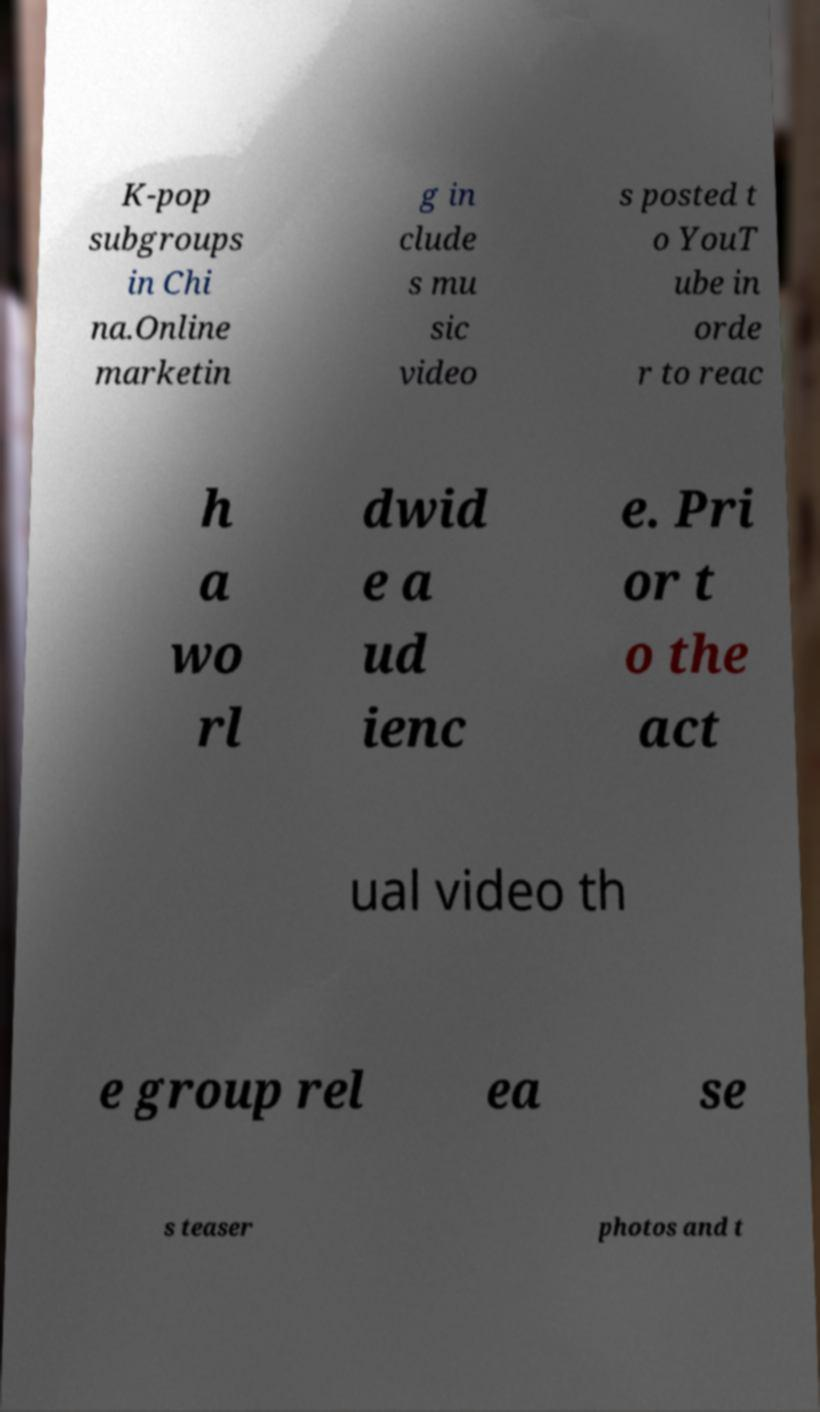What messages or text are displayed in this image? I need them in a readable, typed format. K-pop subgroups in Chi na.Online marketin g in clude s mu sic video s posted t o YouT ube in orde r to reac h a wo rl dwid e a ud ienc e. Pri or t o the act ual video th e group rel ea se s teaser photos and t 